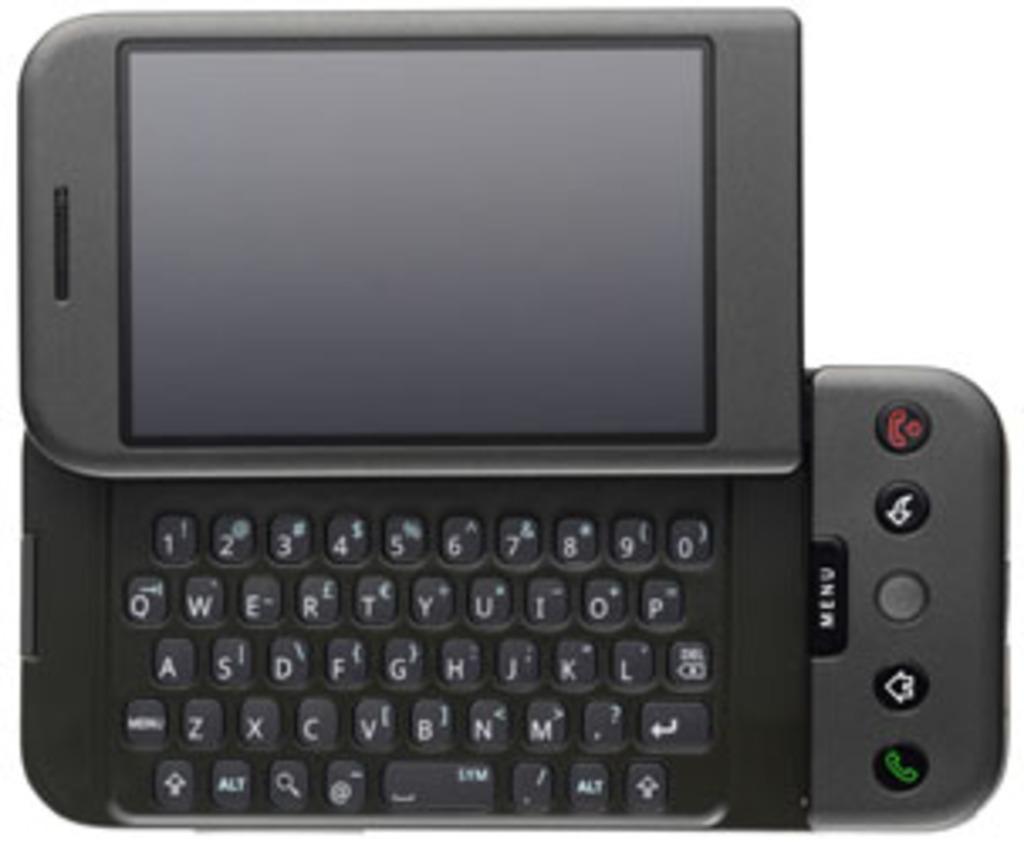What is the largest button on the keyboard for?
Ensure brevity in your answer.  Menu. 